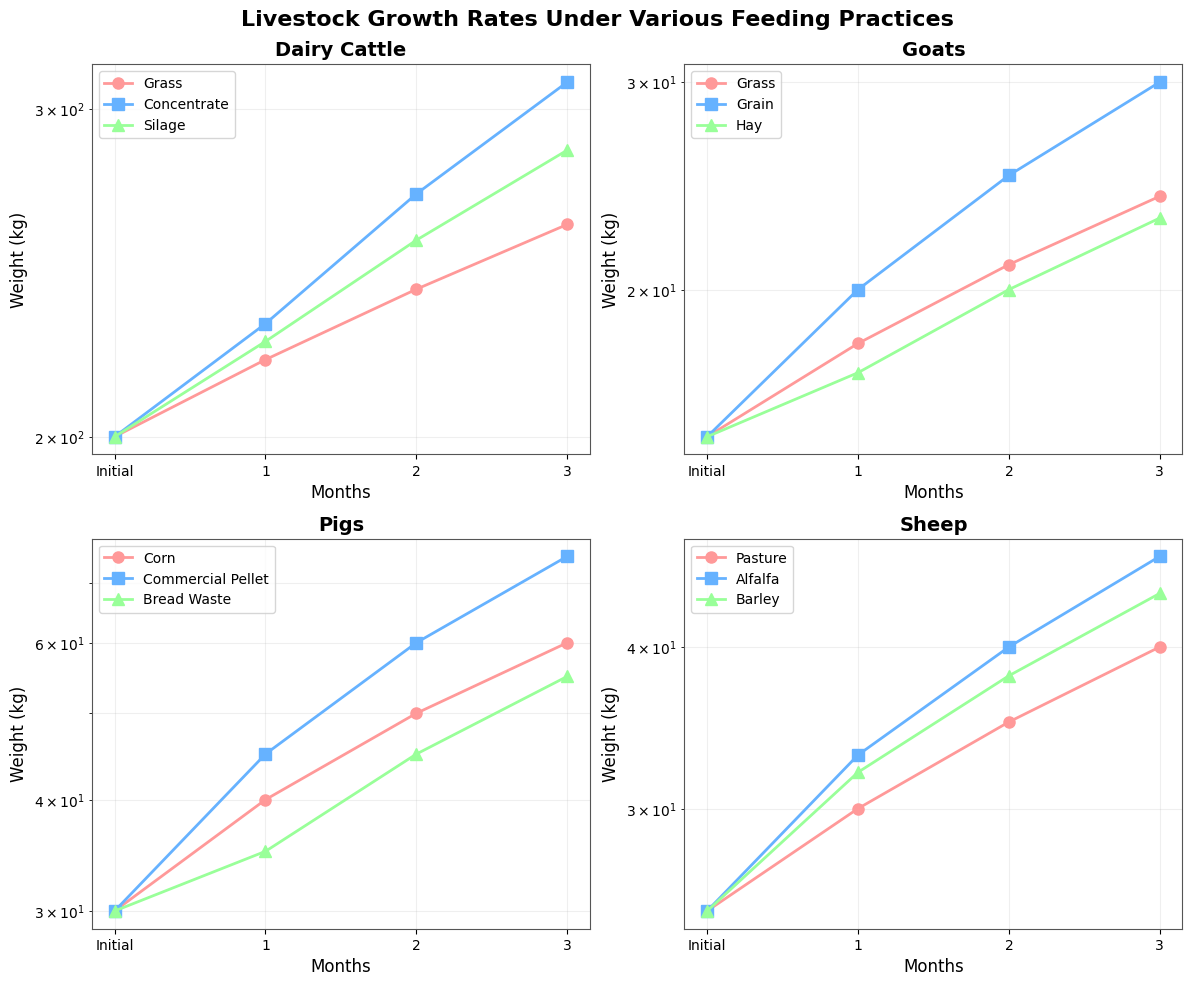What is the title of the figure? The title of the figure is displayed at the top of the subplot. By looking at the top center of the figure, you can see the text "Livestock Growth Rates Under Various Feeding Practices".
Answer: Livestock Growth Rates Under Various Feeding Practices How many farm types are shown in the figure? The figure shows four subplots, each representing a different farm type, as indicated by the titles of the subplots: "Dairy Cattle", "Goats", "Pigs", and "Sheep".
Answer: 4 Which feed type for Dairy Cattle results in the highest weight after 3 months? By looking at the "Dairy Cattle" subplot, you can see that the line representing "Concentrate" has the highest point at the '3 Months' mark compared to "Grass" and "Silage".
Answer: Concentrate What is the weight difference between the initial and final weight for Goats fed with Grain? In the "Goats" subplot, locate the "Grain" line. The initial weight is 15 kg, and the weight after 3 months is 30 kg. The difference is calculated as 30 kg - 15 kg.
Answer: 15 kg Which farm type shows the most significant weight gain for any feed type at the 3-month mark? By comparing the end points of all lines across the four subplots, you can see that in the "Pigs" subplot, the "Commercial Pellet" line ends at the highest point (75 kg) after 3 months.
Answer: Pigs How does the weight gain for Sheep fed with Alfalfa compare to those fed with Barley after 2 months? In the "Sheep" subplot, compare the weight at the '2 Months' mark for "Alfalfa" and "Barley". "Alfalfa" reaches 40 kg, while "Barley" reaches 38 kg.
Answer: Alfalfa > Barley What is the initial weight for all the livestock types? The initial weight for each livestock type is found at the leftmost point of each subplot. For Dairy Cattle, it is 200 kg, for Goats it is 15 kg, for Pigs it is 30 kg, and for Sheep it is 25 kg.
Answer: Dairy Cattle: 200 kg, Goats: 15 kg, Pigs: 30 kg, Sheep: 25 kg Calculate the average weight gain for Pigs fed with Corn over the first month. In the "Pigs" subplot, the initial weight for "Corn" is 30 kg and the weight after 1 month is 40 kg. The gain is 40 kg - 30 kg = 10 kg. Since there is only one month, the average gain is 10 kg / 1 = 10 kg.
Answer: 10 kg Explain why a log scale is used on the y-axis. A log scale is often used when the data spans several orders of magnitude. It helps to compress the scale while allowing you to compare percentage changes rather than absolute changes, making it easier to observe growth trends in weights that vastly differ.
Answer: To compare growth trends across vastly different ranges 